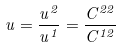Convert formula to latex. <formula><loc_0><loc_0><loc_500><loc_500>u = \frac { u ^ { 2 } } { u ^ { 1 } } = \frac { C ^ { 2 2 } } { C ^ { 1 2 } }</formula> 